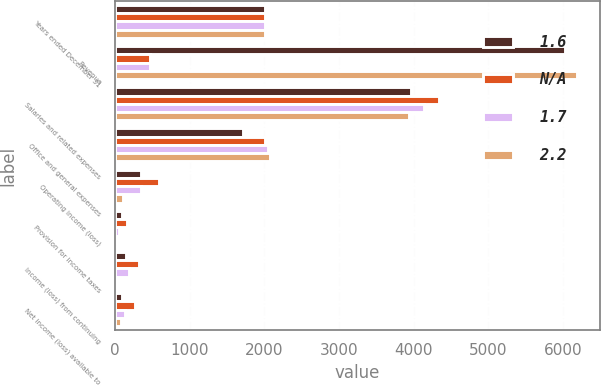Convert chart. <chart><loc_0><loc_0><loc_500><loc_500><stacked_bar_chart><ecel><fcel>Years ended December 31<fcel>Revenue<fcel>Salaries and related expenses<fcel>Office and general expenses<fcel>Operating income (loss)<fcel>Provision for income taxes<fcel>Income (loss) from continuing<fcel>Net income (loss) available to<nl><fcel>1.6<fcel>2009<fcel>6027.6<fcel>3961.2<fcel>1720.5<fcel>341.3<fcel>90.1<fcel>143.4<fcel>93.6<nl><fcel>nan<fcel>2008<fcel>467<fcel>4342.6<fcel>2013.3<fcel>589.7<fcel>156.6<fcel>318<fcel>265.2<nl><fcel>1.7<fcel>2007<fcel>467<fcel>4139.2<fcel>2044.8<fcel>344.3<fcel>58.9<fcel>184.3<fcel>131.3<nl><fcel>2.2<fcel>2006<fcel>6190.8<fcel>3944.1<fcel>2079<fcel>106<fcel>18.7<fcel>16.7<fcel>79.3<nl></chart> 